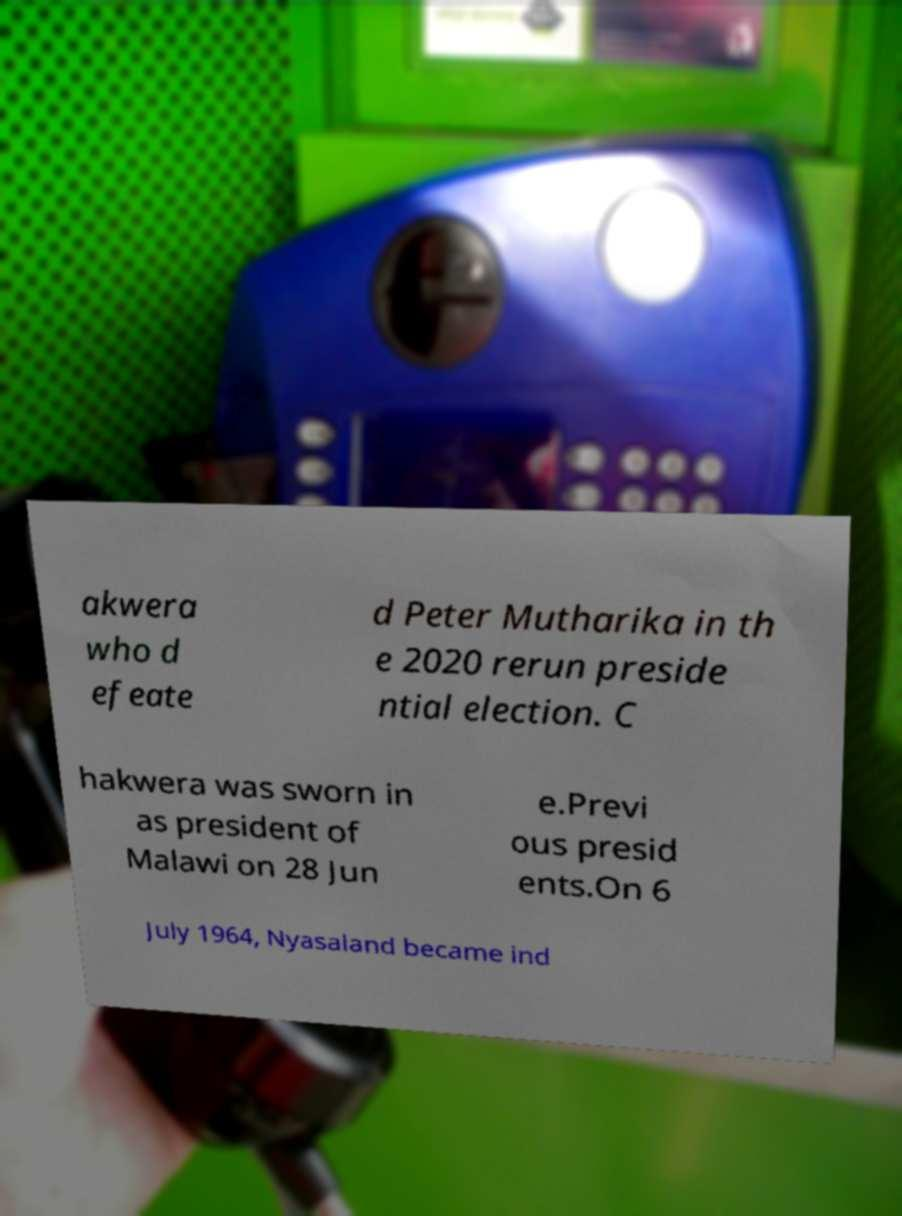There's text embedded in this image that I need extracted. Can you transcribe it verbatim? akwera who d efeate d Peter Mutharika in th e 2020 rerun preside ntial election. C hakwera was sworn in as president of Malawi on 28 Jun e.Previ ous presid ents.On 6 July 1964, Nyasaland became ind 